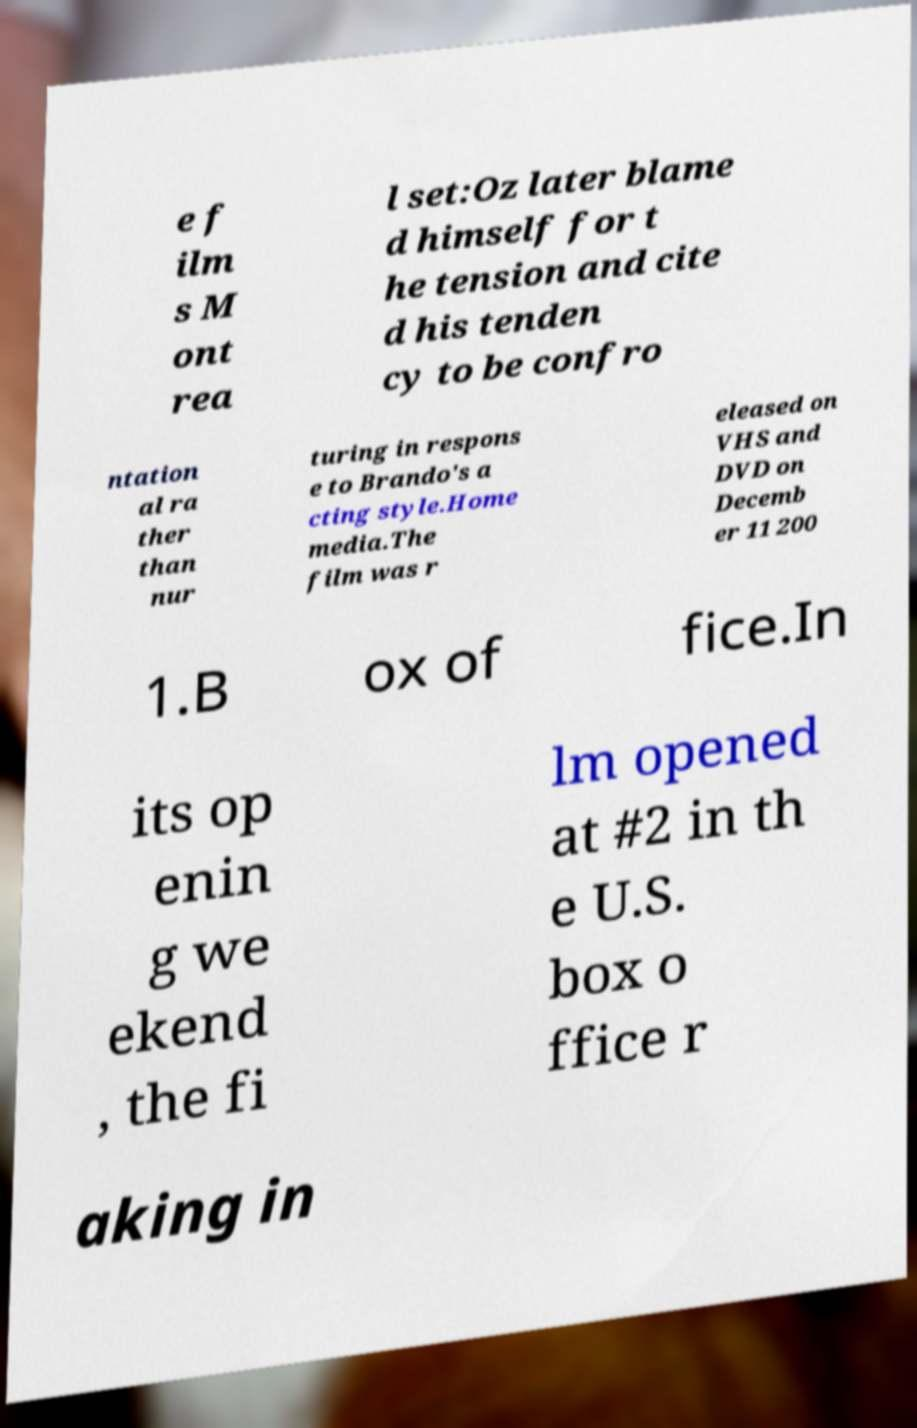Can you read and provide the text displayed in the image?This photo seems to have some interesting text. Can you extract and type it out for me? e f ilm s M ont rea l set:Oz later blame d himself for t he tension and cite d his tenden cy to be confro ntation al ra ther than nur turing in respons e to Brando's a cting style.Home media.The film was r eleased on VHS and DVD on Decemb er 11 200 1.B ox of fice.In its op enin g we ekend , the fi lm opened at #2 in th e U.S. box o ffice r aking in 